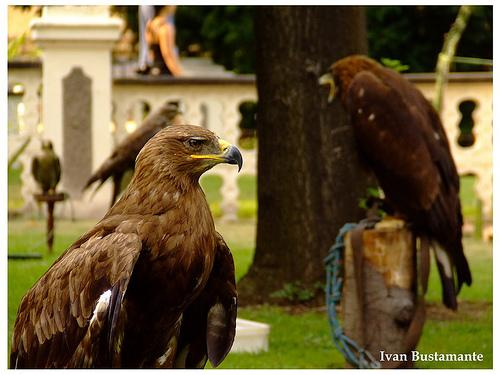Identify the main elements in the image and their actions or positions. A bird with a yellow and black beak sits on a wooden stand, facing forward, while another bird with an open beak perches on a stump nearby, and a woman leans against a low wall. Briefly describe the scene captured in the image. In a grassy area, a brown bird with an open beak sits on a perch, while a woman walks nearby and a large tree trunk is visible in the background. Focus on the main subject and describe their appearance and actions. A bird of prey with a distinct blue beak and white mouth sits on a perch, tethered by a blue rope, with its beak wide open and eyes gazing forward. Give a concise description of the main subject and the setting in the image. A bird with a sharp beak is perched on a post with a chain, surrounded by green grass and large tree trunks, with a woman walking by in the distance. Provide a brief overview of the scene depicted in the photograph. In a grassy setting with lush green grass and large tree trunks, several birds are perched on posts or stands, while people walk around observing them. Explain the primary subject of the image and the context in which they appear. A bird with a striking yellow and black beak is perched on a stump in a grassy area with other birds and a woman walking by, as a large tree trunk stands in the background. Mention the primary focus of the image and the action taking place. A brown bird of prey with its mouth open is perched on a post, tethered by a blue cord, while a woman in an orange shirt walks by in the distance. Summarize the main elements and actions occurring in the image. Birds with diverse features, like a parrot on a stand and another bird with an open beak, perch on wooden posts, while a woman in an orange shirt walks in the background. Mention the prominent object in the image and its characteristics. A brown falcon with a black and yellow beak is sitting on a stump, tethered with a blue woven cord, with its mouth open and a slanted black eye visible. Express the main activity taking place in the image. A parrot stands on a perch with its beak open, while other birds are in a pen and people walk by on the manicured green grass nearby. 